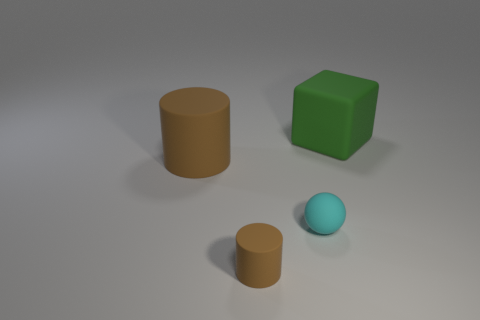Add 1 tiny green spheres. How many objects exist? 5 Subtract all blocks. How many objects are left? 3 Subtract all purple blocks. How many brown balls are left? 0 Subtract all small cyan rubber balls. Subtract all large green matte blocks. How many objects are left? 2 Add 3 tiny brown things. How many tiny brown things are left? 4 Add 4 large red blocks. How many large red blocks exist? 4 Subtract 1 brown cylinders. How many objects are left? 3 Subtract all red cubes. Subtract all green balls. How many cubes are left? 1 